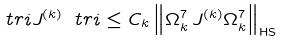Convert formula to latex. <formula><loc_0><loc_0><loc_500><loc_500>\ t r i J ^ { ( k ) } \ t r i \leq C _ { k } \left \| \Omega _ { k } ^ { 7 } \, J ^ { ( k ) } \Omega _ { k } ^ { 7 } \right \| _ { \text {HS} } \,</formula> 